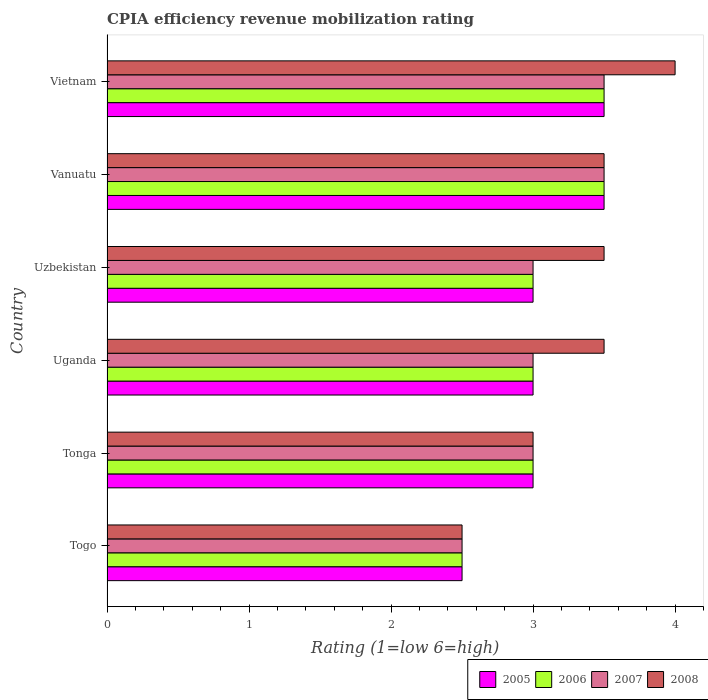How many groups of bars are there?
Offer a terse response. 6. Are the number of bars on each tick of the Y-axis equal?
Give a very brief answer. Yes. How many bars are there on the 6th tick from the bottom?
Provide a short and direct response. 4. What is the label of the 2nd group of bars from the top?
Offer a very short reply. Vanuatu. In how many cases, is the number of bars for a given country not equal to the number of legend labels?
Your answer should be compact. 0. Across all countries, what is the maximum CPIA rating in 2008?
Your response must be concise. 4. In which country was the CPIA rating in 2008 maximum?
Keep it short and to the point. Vietnam. In which country was the CPIA rating in 2005 minimum?
Provide a short and direct response. Togo. What is the total CPIA rating in 2007 in the graph?
Provide a succinct answer. 18.5. What is the difference between the CPIA rating in 2006 in Togo and that in Tonga?
Offer a terse response. -0.5. What is the difference between the CPIA rating in 2006 in Tonga and the CPIA rating in 2005 in Uganda?
Ensure brevity in your answer.  0. What is the average CPIA rating in 2006 per country?
Provide a succinct answer. 3.08. In how many countries, is the CPIA rating in 2006 greater than 2.8 ?
Offer a terse response. 5. What is the ratio of the CPIA rating in 2005 in Tonga to that in Vietnam?
Give a very brief answer. 0.86. Is the difference between the CPIA rating in 2006 in Uganda and Vietnam greater than the difference between the CPIA rating in 2008 in Uganda and Vietnam?
Your answer should be very brief. No. What is the difference between the highest and the second highest CPIA rating in 2006?
Ensure brevity in your answer.  0. In how many countries, is the CPIA rating in 2007 greater than the average CPIA rating in 2007 taken over all countries?
Provide a short and direct response. 2. Is it the case that in every country, the sum of the CPIA rating in 2005 and CPIA rating in 2006 is greater than the sum of CPIA rating in 2008 and CPIA rating in 2007?
Your answer should be very brief. No. What does the 3rd bar from the bottom in Vanuatu represents?
Your answer should be compact. 2007. Are all the bars in the graph horizontal?
Your answer should be compact. Yes. What is the difference between two consecutive major ticks on the X-axis?
Ensure brevity in your answer.  1. Are the values on the major ticks of X-axis written in scientific E-notation?
Offer a terse response. No. Does the graph contain any zero values?
Keep it short and to the point. No. Where does the legend appear in the graph?
Keep it short and to the point. Bottom right. How are the legend labels stacked?
Give a very brief answer. Horizontal. What is the title of the graph?
Your answer should be compact. CPIA efficiency revenue mobilization rating. Does "2007" appear as one of the legend labels in the graph?
Your response must be concise. Yes. What is the label or title of the X-axis?
Ensure brevity in your answer.  Rating (1=low 6=high). What is the label or title of the Y-axis?
Offer a very short reply. Country. What is the Rating (1=low 6=high) of 2005 in Togo?
Your answer should be compact. 2.5. What is the Rating (1=low 6=high) in 2006 in Togo?
Provide a short and direct response. 2.5. What is the Rating (1=low 6=high) of 2007 in Togo?
Your answer should be very brief. 2.5. What is the Rating (1=low 6=high) of 2005 in Tonga?
Your response must be concise. 3. What is the Rating (1=low 6=high) in 2008 in Tonga?
Provide a succinct answer. 3. What is the Rating (1=low 6=high) of 2005 in Uganda?
Provide a short and direct response. 3. What is the Rating (1=low 6=high) in 2007 in Uganda?
Ensure brevity in your answer.  3. What is the Rating (1=low 6=high) in 2008 in Uganda?
Keep it short and to the point. 3.5. What is the Rating (1=low 6=high) of 2005 in Uzbekistan?
Provide a succinct answer. 3. What is the Rating (1=low 6=high) in 2007 in Uzbekistan?
Keep it short and to the point. 3. What is the Rating (1=low 6=high) of 2008 in Uzbekistan?
Make the answer very short. 3.5. What is the Rating (1=low 6=high) of 2005 in Vanuatu?
Keep it short and to the point. 3.5. What is the Rating (1=low 6=high) in 2005 in Vietnam?
Your answer should be very brief. 3.5. What is the Rating (1=low 6=high) of 2006 in Vietnam?
Provide a succinct answer. 3.5. What is the Rating (1=low 6=high) in 2007 in Vietnam?
Provide a succinct answer. 3.5. Across all countries, what is the maximum Rating (1=low 6=high) of 2006?
Your answer should be compact. 3.5. Across all countries, what is the maximum Rating (1=low 6=high) in 2008?
Offer a terse response. 4. Across all countries, what is the minimum Rating (1=low 6=high) in 2005?
Provide a succinct answer. 2.5. Across all countries, what is the minimum Rating (1=low 6=high) in 2007?
Keep it short and to the point. 2.5. What is the total Rating (1=low 6=high) in 2006 in the graph?
Your answer should be compact. 18.5. What is the difference between the Rating (1=low 6=high) of 2006 in Togo and that in Tonga?
Ensure brevity in your answer.  -0.5. What is the difference between the Rating (1=low 6=high) of 2007 in Togo and that in Tonga?
Your response must be concise. -0.5. What is the difference between the Rating (1=low 6=high) in 2008 in Togo and that in Tonga?
Your answer should be compact. -0.5. What is the difference between the Rating (1=low 6=high) in 2006 in Togo and that in Uganda?
Offer a very short reply. -0.5. What is the difference between the Rating (1=low 6=high) in 2007 in Togo and that in Uganda?
Offer a very short reply. -0.5. What is the difference between the Rating (1=low 6=high) of 2008 in Togo and that in Uganda?
Your answer should be compact. -1. What is the difference between the Rating (1=low 6=high) in 2005 in Togo and that in Uzbekistan?
Your response must be concise. -0.5. What is the difference between the Rating (1=low 6=high) of 2006 in Togo and that in Uzbekistan?
Provide a short and direct response. -0.5. What is the difference between the Rating (1=low 6=high) in 2008 in Togo and that in Uzbekistan?
Make the answer very short. -1. What is the difference between the Rating (1=low 6=high) in 2005 in Togo and that in Vanuatu?
Offer a terse response. -1. What is the difference between the Rating (1=low 6=high) in 2006 in Togo and that in Vietnam?
Your response must be concise. -1. What is the difference between the Rating (1=low 6=high) in 2008 in Togo and that in Vietnam?
Give a very brief answer. -1.5. What is the difference between the Rating (1=low 6=high) of 2007 in Tonga and that in Uganda?
Provide a short and direct response. 0. What is the difference between the Rating (1=low 6=high) of 2005 in Tonga and that in Uzbekistan?
Make the answer very short. 0. What is the difference between the Rating (1=low 6=high) in 2008 in Tonga and that in Uzbekistan?
Give a very brief answer. -0.5. What is the difference between the Rating (1=low 6=high) in 2005 in Tonga and that in Vanuatu?
Ensure brevity in your answer.  -0.5. What is the difference between the Rating (1=low 6=high) of 2006 in Tonga and that in Vanuatu?
Your response must be concise. -0.5. What is the difference between the Rating (1=low 6=high) in 2007 in Tonga and that in Vanuatu?
Provide a succinct answer. -0.5. What is the difference between the Rating (1=low 6=high) of 2006 in Uganda and that in Uzbekistan?
Ensure brevity in your answer.  0. What is the difference between the Rating (1=low 6=high) in 2007 in Uganda and that in Uzbekistan?
Your answer should be compact. 0. What is the difference between the Rating (1=low 6=high) of 2006 in Uganda and that in Vanuatu?
Your answer should be compact. -0.5. What is the difference between the Rating (1=low 6=high) of 2008 in Uganda and that in Vanuatu?
Offer a terse response. 0. What is the difference between the Rating (1=low 6=high) in 2005 in Uganda and that in Vietnam?
Your response must be concise. -0.5. What is the difference between the Rating (1=low 6=high) of 2006 in Uganda and that in Vietnam?
Your answer should be very brief. -0.5. What is the difference between the Rating (1=low 6=high) of 2007 in Uganda and that in Vietnam?
Your answer should be very brief. -0.5. What is the difference between the Rating (1=low 6=high) in 2008 in Uganda and that in Vietnam?
Provide a short and direct response. -0.5. What is the difference between the Rating (1=low 6=high) in 2005 in Uzbekistan and that in Vanuatu?
Your response must be concise. -0.5. What is the difference between the Rating (1=low 6=high) in 2007 in Uzbekistan and that in Vanuatu?
Offer a terse response. -0.5. What is the difference between the Rating (1=low 6=high) in 2008 in Uzbekistan and that in Vanuatu?
Ensure brevity in your answer.  0. What is the difference between the Rating (1=low 6=high) of 2005 in Uzbekistan and that in Vietnam?
Your answer should be compact. -0.5. What is the difference between the Rating (1=low 6=high) in 2008 in Uzbekistan and that in Vietnam?
Ensure brevity in your answer.  -0.5. What is the difference between the Rating (1=low 6=high) of 2006 in Vanuatu and that in Vietnam?
Offer a very short reply. 0. What is the difference between the Rating (1=low 6=high) of 2008 in Vanuatu and that in Vietnam?
Your answer should be very brief. -0.5. What is the difference between the Rating (1=low 6=high) in 2005 in Togo and the Rating (1=low 6=high) in 2007 in Tonga?
Provide a short and direct response. -0.5. What is the difference between the Rating (1=low 6=high) of 2005 in Togo and the Rating (1=low 6=high) of 2008 in Tonga?
Keep it short and to the point. -0.5. What is the difference between the Rating (1=low 6=high) in 2006 in Togo and the Rating (1=low 6=high) in 2007 in Tonga?
Ensure brevity in your answer.  -0.5. What is the difference between the Rating (1=low 6=high) in 2006 in Togo and the Rating (1=low 6=high) in 2008 in Tonga?
Keep it short and to the point. -0.5. What is the difference between the Rating (1=low 6=high) of 2005 in Togo and the Rating (1=low 6=high) of 2006 in Uganda?
Offer a very short reply. -0.5. What is the difference between the Rating (1=low 6=high) of 2005 in Togo and the Rating (1=low 6=high) of 2007 in Uganda?
Your answer should be very brief. -0.5. What is the difference between the Rating (1=low 6=high) of 2005 in Togo and the Rating (1=low 6=high) of 2008 in Uganda?
Give a very brief answer. -1. What is the difference between the Rating (1=low 6=high) of 2005 in Togo and the Rating (1=low 6=high) of 2006 in Uzbekistan?
Offer a very short reply. -0.5. What is the difference between the Rating (1=low 6=high) of 2005 in Togo and the Rating (1=low 6=high) of 2007 in Uzbekistan?
Provide a succinct answer. -0.5. What is the difference between the Rating (1=low 6=high) of 2005 in Togo and the Rating (1=low 6=high) of 2008 in Uzbekistan?
Offer a very short reply. -1. What is the difference between the Rating (1=low 6=high) of 2006 in Togo and the Rating (1=low 6=high) of 2008 in Uzbekistan?
Keep it short and to the point. -1. What is the difference between the Rating (1=low 6=high) in 2007 in Togo and the Rating (1=low 6=high) in 2008 in Uzbekistan?
Offer a very short reply. -1. What is the difference between the Rating (1=low 6=high) of 2005 in Togo and the Rating (1=low 6=high) of 2006 in Vanuatu?
Provide a succinct answer. -1. What is the difference between the Rating (1=low 6=high) of 2005 in Togo and the Rating (1=low 6=high) of 2007 in Vanuatu?
Ensure brevity in your answer.  -1. What is the difference between the Rating (1=low 6=high) of 2006 in Togo and the Rating (1=low 6=high) of 2008 in Vanuatu?
Your answer should be very brief. -1. What is the difference between the Rating (1=low 6=high) in 2007 in Togo and the Rating (1=low 6=high) in 2008 in Vanuatu?
Offer a very short reply. -1. What is the difference between the Rating (1=low 6=high) in 2005 in Togo and the Rating (1=low 6=high) in 2007 in Vietnam?
Give a very brief answer. -1. What is the difference between the Rating (1=low 6=high) of 2007 in Togo and the Rating (1=low 6=high) of 2008 in Vietnam?
Ensure brevity in your answer.  -1.5. What is the difference between the Rating (1=low 6=high) in 2006 in Tonga and the Rating (1=low 6=high) in 2007 in Uganda?
Provide a succinct answer. 0. What is the difference between the Rating (1=low 6=high) of 2006 in Tonga and the Rating (1=low 6=high) of 2008 in Uganda?
Ensure brevity in your answer.  -0.5. What is the difference between the Rating (1=low 6=high) of 2005 in Tonga and the Rating (1=low 6=high) of 2006 in Uzbekistan?
Your answer should be very brief. 0. What is the difference between the Rating (1=low 6=high) of 2005 in Tonga and the Rating (1=low 6=high) of 2007 in Uzbekistan?
Provide a short and direct response. 0. What is the difference between the Rating (1=low 6=high) in 2006 in Tonga and the Rating (1=low 6=high) in 2007 in Uzbekistan?
Provide a short and direct response. 0. What is the difference between the Rating (1=low 6=high) of 2006 in Tonga and the Rating (1=low 6=high) of 2008 in Uzbekistan?
Make the answer very short. -0.5. What is the difference between the Rating (1=low 6=high) of 2007 in Tonga and the Rating (1=low 6=high) of 2008 in Uzbekistan?
Your response must be concise. -0.5. What is the difference between the Rating (1=low 6=high) of 2005 in Tonga and the Rating (1=low 6=high) of 2008 in Vanuatu?
Keep it short and to the point. -0.5. What is the difference between the Rating (1=low 6=high) of 2006 in Tonga and the Rating (1=low 6=high) of 2008 in Vanuatu?
Keep it short and to the point. -0.5. What is the difference between the Rating (1=low 6=high) of 2005 in Tonga and the Rating (1=low 6=high) of 2006 in Vietnam?
Offer a very short reply. -0.5. What is the difference between the Rating (1=low 6=high) of 2005 in Tonga and the Rating (1=low 6=high) of 2007 in Vietnam?
Make the answer very short. -0.5. What is the difference between the Rating (1=low 6=high) in 2005 in Tonga and the Rating (1=low 6=high) in 2008 in Vietnam?
Your response must be concise. -1. What is the difference between the Rating (1=low 6=high) of 2006 in Uganda and the Rating (1=low 6=high) of 2008 in Uzbekistan?
Make the answer very short. -0.5. What is the difference between the Rating (1=low 6=high) of 2006 in Uganda and the Rating (1=low 6=high) of 2007 in Vanuatu?
Your answer should be compact. -0.5. What is the difference between the Rating (1=low 6=high) in 2006 in Uganda and the Rating (1=low 6=high) in 2008 in Vietnam?
Your answer should be compact. -1. What is the difference between the Rating (1=low 6=high) in 2007 in Uganda and the Rating (1=low 6=high) in 2008 in Vietnam?
Your answer should be very brief. -1. What is the difference between the Rating (1=low 6=high) of 2005 in Uzbekistan and the Rating (1=low 6=high) of 2006 in Vanuatu?
Your response must be concise. -0.5. What is the difference between the Rating (1=low 6=high) of 2005 in Uzbekistan and the Rating (1=low 6=high) of 2007 in Vanuatu?
Your response must be concise. -0.5. What is the difference between the Rating (1=low 6=high) in 2005 in Uzbekistan and the Rating (1=low 6=high) in 2008 in Vanuatu?
Give a very brief answer. -0.5. What is the difference between the Rating (1=low 6=high) of 2006 in Uzbekistan and the Rating (1=low 6=high) of 2007 in Vanuatu?
Your response must be concise. -0.5. What is the difference between the Rating (1=low 6=high) of 2005 in Uzbekistan and the Rating (1=low 6=high) of 2006 in Vietnam?
Make the answer very short. -0.5. What is the difference between the Rating (1=low 6=high) of 2006 in Uzbekistan and the Rating (1=low 6=high) of 2007 in Vietnam?
Ensure brevity in your answer.  -0.5. What is the difference between the Rating (1=low 6=high) in 2005 in Vanuatu and the Rating (1=low 6=high) in 2006 in Vietnam?
Provide a short and direct response. 0. What is the difference between the Rating (1=low 6=high) of 2005 in Vanuatu and the Rating (1=low 6=high) of 2008 in Vietnam?
Offer a very short reply. -0.5. What is the difference between the Rating (1=low 6=high) in 2006 in Vanuatu and the Rating (1=low 6=high) in 2007 in Vietnam?
Make the answer very short. 0. What is the average Rating (1=low 6=high) of 2005 per country?
Provide a succinct answer. 3.08. What is the average Rating (1=low 6=high) in 2006 per country?
Ensure brevity in your answer.  3.08. What is the average Rating (1=low 6=high) in 2007 per country?
Give a very brief answer. 3.08. What is the average Rating (1=low 6=high) in 2008 per country?
Give a very brief answer. 3.33. What is the difference between the Rating (1=low 6=high) of 2006 and Rating (1=low 6=high) of 2008 in Togo?
Your response must be concise. 0. What is the difference between the Rating (1=low 6=high) in 2005 and Rating (1=low 6=high) in 2006 in Tonga?
Offer a terse response. 0. What is the difference between the Rating (1=low 6=high) of 2005 and Rating (1=low 6=high) of 2007 in Tonga?
Provide a succinct answer. 0. What is the difference between the Rating (1=low 6=high) in 2007 and Rating (1=low 6=high) in 2008 in Tonga?
Make the answer very short. 0. What is the difference between the Rating (1=low 6=high) of 2006 and Rating (1=low 6=high) of 2007 in Uganda?
Keep it short and to the point. 0. What is the difference between the Rating (1=low 6=high) in 2007 and Rating (1=low 6=high) in 2008 in Uganda?
Offer a terse response. -0.5. What is the difference between the Rating (1=low 6=high) in 2005 and Rating (1=low 6=high) in 2007 in Uzbekistan?
Your answer should be very brief. 0. What is the difference between the Rating (1=low 6=high) in 2005 and Rating (1=low 6=high) in 2008 in Uzbekistan?
Offer a terse response. -0.5. What is the difference between the Rating (1=low 6=high) of 2005 and Rating (1=low 6=high) of 2006 in Vanuatu?
Offer a very short reply. 0. What is the difference between the Rating (1=low 6=high) in 2006 and Rating (1=low 6=high) in 2007 in Vanuatu?
Offer a very short reply. 0. What is the difference between the Rating (1=low 6=high) of 2006 and Rating (1=low 6=high) of 2008 in Vanuatu?
Offer a terse response. 0. What is the difference between the Rating (1=low 6=high) in 2007 and Rating (1=low 6=high) in 2008 in Vanuatu?
Give a very brief answer. 0. What is the difference between the Rating (1=low 6=high) of 2005 and Rating (1=low 6=high) of 2006 in Vietnam?
Give a very brief answer. 0. What is the difference between the Rating (1=low 6=high) in 2005 and Rating (1=low 6=high) in 2008 in Vietnam?
Your response must be concise. -0.5. What is the difference between the Rating (1=low 6=high) in 2006 and Rating (1=low 6=high) in 2007 in Vietnam?
Provide a succinct answer. 0. What is the difference between the Rating (1=low 6=high) of 2007 and Rating (1=low 6=high) of 2008 in Vietnam?
Your answer should be very brief. -0.5. What is the ratio of the Rating (1=low 6=high) in 2005 in Togo to that in Tonga?
Offer a very short reply. 0.83. What is the ratio of the Rating (1=low 6=high) in 2006 in Togo to that in Tonga?
Offer a terse response. 0.83. What is the ratio of the Rating (1=low 6=high) of 2005 in Togo to that in Uganda?
Your response must be concise. 0.83. What is the ratio of the Rating (1=low 6=high) in 2006 in Togo to that in Uganda?
Keep it short and to the point. 0.83. What is the ratio of the Rating (1=low 6=high) in 2007 in Togo to that in Uganda?
Your answer should be compact. 0.83. What is the ratio of the Rating (1=low 6=high) of 2006 in Togo to that in Uzbekistan?
Provide a short and direct response. 0.83. What is the ratio of the Rating (1=low 6=high) of 2005 in Togo to that in Vanuatu?
Offer a very short reply. 0.71. What is the ratio of the Rating (1=low 6=high) in 2006 in Togo to that in Vanuatu?
Your answer should be very brief. 0.71. What is the ratio of the Rating (1=low 6=high) of 2005 in Togo to that in Vietnam?
Provide a short and direct response. 0.71. What is the ratio of the Rating (1=low 6=high) of 2005 in Tonga to that in Uganda?
Provide a short and direct response. 1. What is the ratio of the Rating (1=low 6=high) of 2006 in Tonga to that in Uganda?
Give a very brief answer. 1. What is the ratio of the Rating (1=low 6=high) in 2006 in Tonga to that in Uzbekistan?
Offer a terse response. 1. What is the ratio of the Rating (1=low 6=high) of 2007 in Tonga to that in Uzbekistan?
Your answer should be compact. 1. What is the ratio of the Rating (1=low 6=high) of 2008 in Tonga to that in Uzbekistan?
Provide a short and direct response. 0.86. What is the ratio of the Rating (1=low 6=high) in 2007 in Tonga to that in Vanuatu?
Provide a short and direct response. 0.86. What is the ratio of the Rating (1=low 6=high) of 2008 in Tonga to that in Vanuatu?
Your answer should be compact. 0.86. What is the ratio of the Rating (1=low 6=high) in 2005 in Tonga to that in Vietnam?
Ensure brevity in your answer.  0.86. What is the ratio of the Rating (1=low 6=high) of 2007 in Tonga to that in Vietnam?
Offer a terse response. 0.86. What is the ratio of the Rating (1=low 6=high) in 2008 in Tonga to that in Vietnam?
Make the answer very short. 0.75. What is the ratio of the Rating (1=low 6=high) in 2005 in Uganda to that in Uzbekistan?
Keep it short and to the point. 1. What is the ratio of the Rating (1=low 6=high) in 2006 in Uganda to that in Uzbekistan?
Provide a short and direct response. 1. What is the ratio of the Rating (1=low 6=high) in 2007 in Uganda to that in Uzbekistan?
Offer a terse response. 1. What is the ratio of the Rating (1=low 6=high) of 2006 in Uganda to that in Vietnam?
Make the answer very short. 0.86. What is the ratio of the Rating (1=low 6=high) in 2008 in Uganda to that in Vietnam?
Your response must be concise. 0.88. What is the ratio of the Rating (1=low 6=high) of 2005 in Uzbekistan to that in Vanuatu?
Offer a terse response. 0.86. What is the ratio of the Rating (1=low 6=high) in 2008 in Uzbekistan to that in Vanuatu?
Ensure brevity in your answer.  1. What is the ratio of the Rating (1=low 6=high) in 2005 in Uzbekistan to that in Vietnam?
Offer a terse response. 0.86. What is the ratio of the Rating (1=low 6=high) in 2006 in Uzbekistan to that in Vietnam?
Offer a terse response. 0.86. What is the ratio of the Rating (1=low 6=high) in 2007 in Uzbekistan to that in Vietnam?
Provide a short and direct response. 0.86. What is the ratio of the Rating (1=low 6=high) in 2008 in Uzbekistan to that in Vietnam?
Your answer should be compact. 0.88. What is the ratio of the Rating (1=low 6=high) in 2005 in Vanuatu to that in Vietnam?
Provide a short and direct response. 1. What is the ratio of the Rating (1=low 6=high) in 2006 in Vanuatu to that in Vietnam?
Offer a terse response. 1. What is the ratio of the Rating (1=low 6=high) in 2007 in Vanuatu to that in Vietnam?
Offer a very short reply. 1. What is the ratio of the Rating (1=low 6=high) of 2008 in Vanuatu to that in Vietnam?
Keep it short and to the point. 0.88. What is the difference between the highest and the lowest Rating (1=low 6=high) of 2006?
Provide a succinct answer. 1. What is the difference between the highest and the lowest Rating (1=low 6=high) of 2008?
Provide a succinct answer. 1.5. 